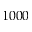<formula> <loc_0><loc_0><loc_500><loc_500>1 0 0 0</formula> 